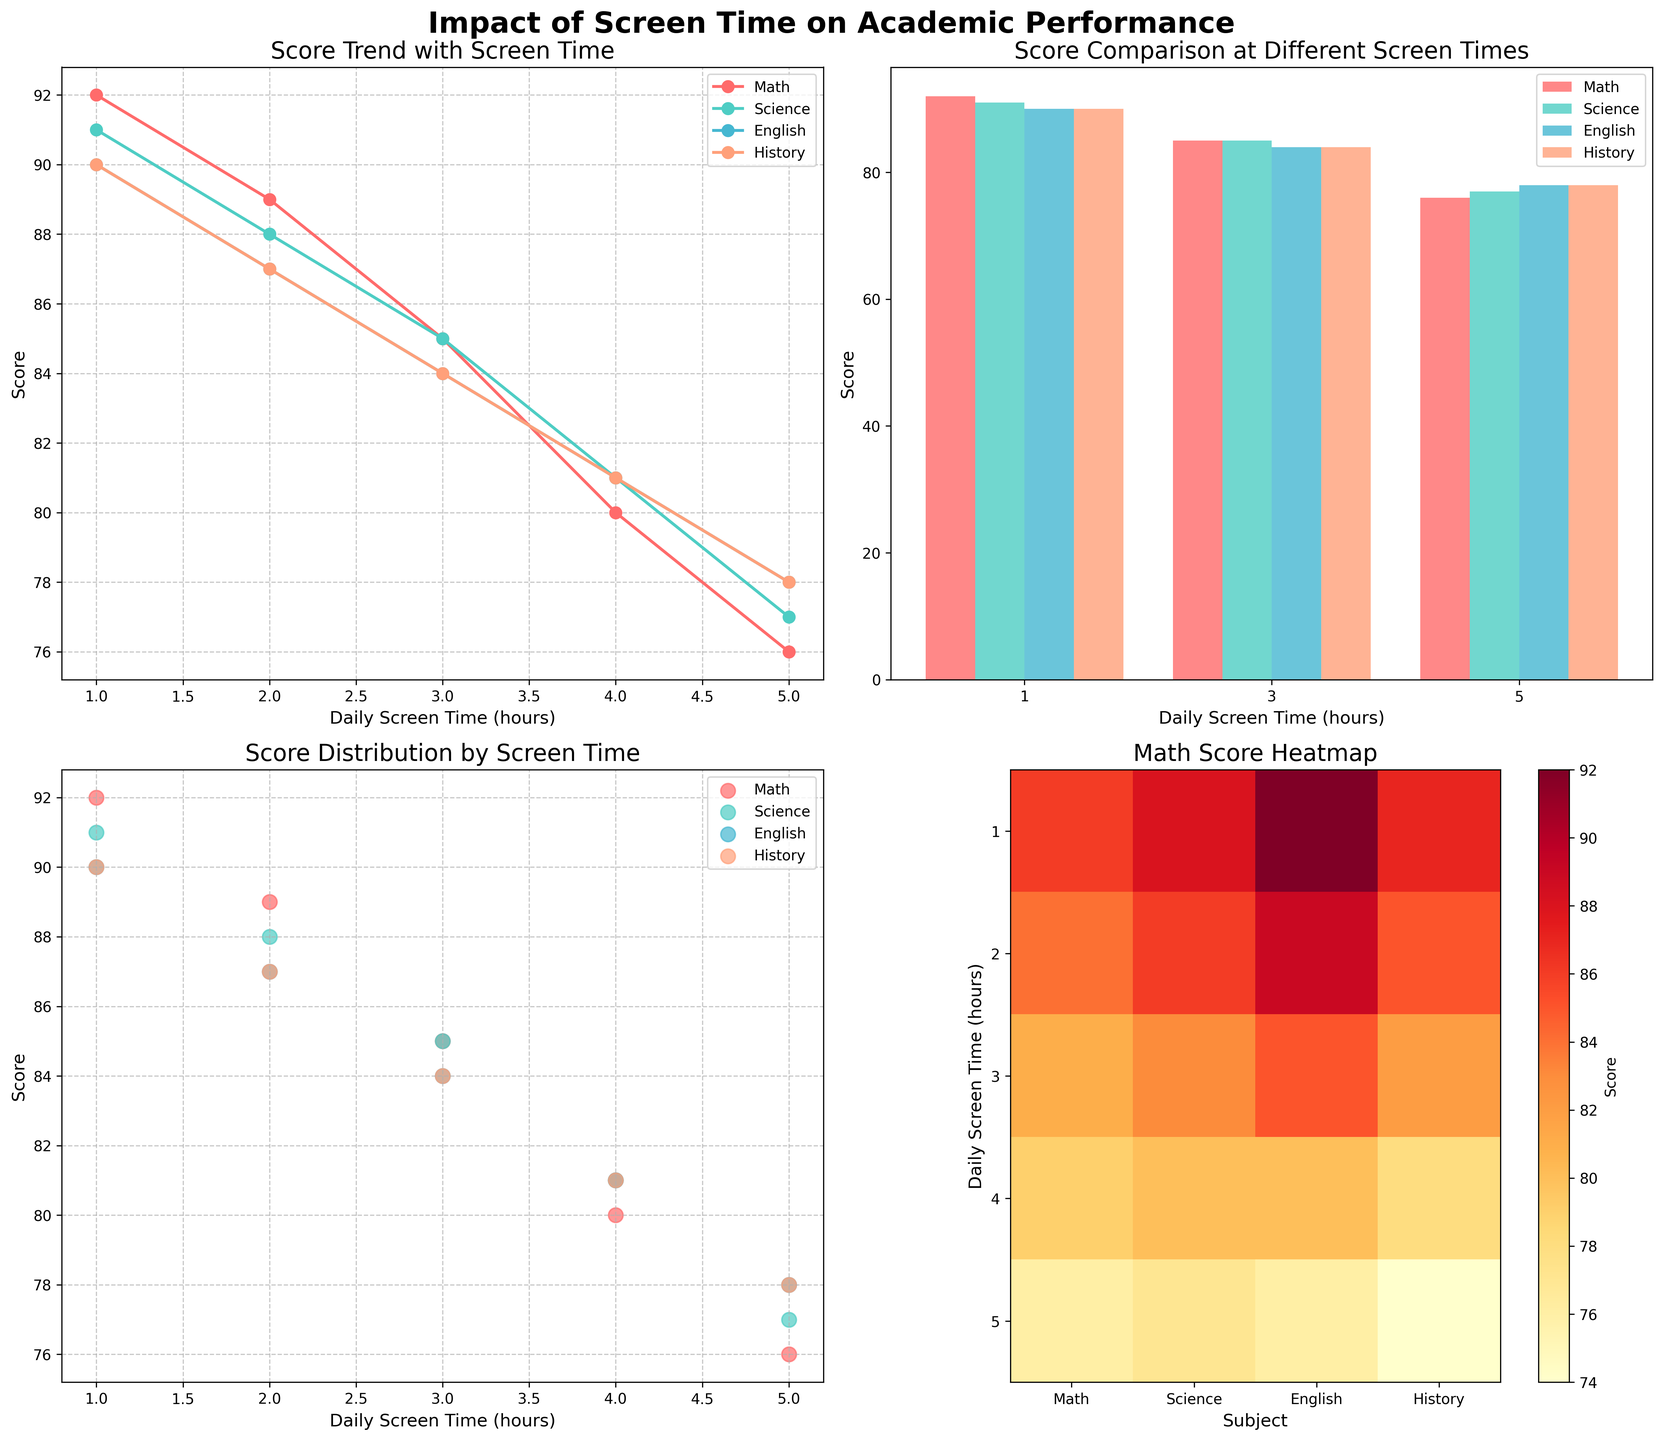Which subject has the highest score at 1 hour of daily screen time in the scatter plot? In the scatter plot, look for the points plotted at 1 hour along the horizontal axis and compare their vertical positions. The highest vertical point represents the highest score.
Answer: Math What can be observed about the trend line for Math scores as daily screen time increases? In the line plot, observe the trend of the Math line as it moves from left to right. The line shows a downward trend from a higher score towards a lower score.
Answer: Decreases Which subject shows the smallest variation in scores with increasing screen time, as seen in the line plot? Check the line plot for each subject and observe the vertical fluctuations. The subject with the least up-down movement demonstrates the smallest variation.
Answer: English What is the average score for Science at 3 hours of daily screen time across all chart types? Identify the score for Science at 3 hours from the line, bar, and scatter plots. It's consistently 82 in all plots. Adding this value three times and dividing by 3 gives (82 + 82 + 82)/3.
Answer: 82 How does the average score for History compare to English at 3 hours of screen time in the bar plot? Look at the bars representing History and English at 3 hours in the bar plot. Compare their heights to find the disparity. History has 82 while English has 81.
Answer: Higher Through which chart type can we best observe the distribution pattern of scores for each subject by screen time? Observe which chart type shows a spread of individual data points. The scatter plot shows distribution with spread dots for each subject by screen time.
Answer: Scatter plot In the heatmap, at which screen time does Math have the highest score? Look at the row in the heatmap labeled 'Math Score' and find the highest value. It's in the cell corresponding to 1 hour of screen time.
Answer: 1 hour Comparing the scatter plot, which subject's scores decrease the most steeply with increasing screen time? In the scatter plot, observe the slope of the points for each subject. The steeper slope indicates a sharper decrease. Math has the steepest decline.
Answer: Math 